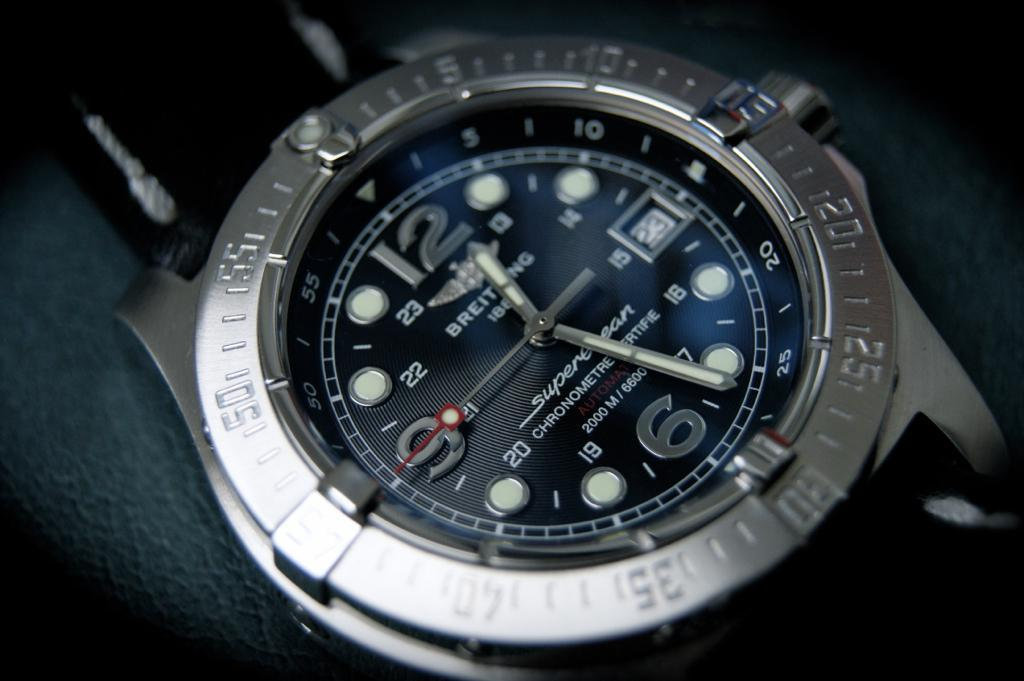<image>
Describe the image concisely. The Breitting watch shows the time as 12:26. 